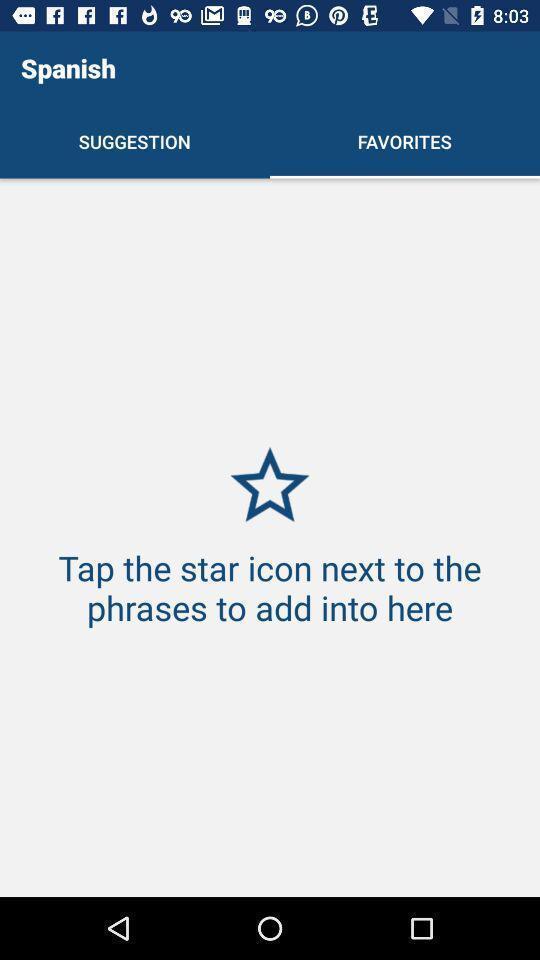Explain the elements present in this screenshot. Screen showing page of an language learning application. 